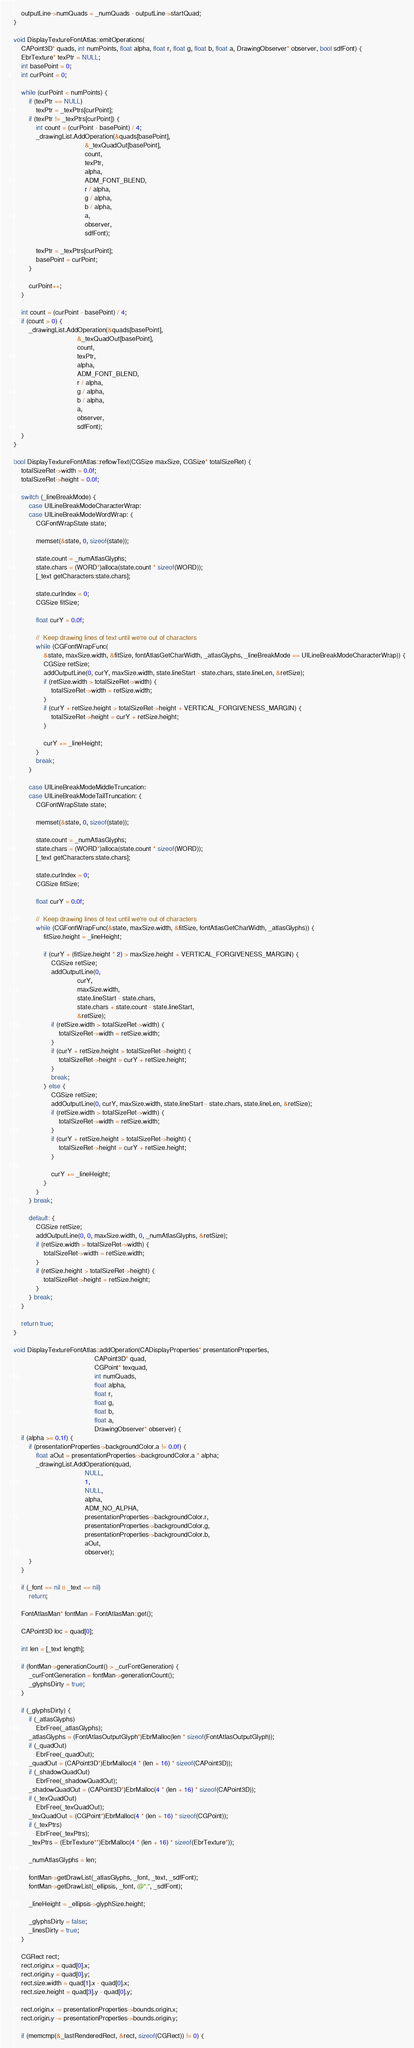<code> <loc_0><loc_0><loc_500><loc_500><_ObjectiveC_>
    outputLine->numQuads = _numQuads - outputLine->startQuad;
}

void DisplayTextureFontAtlas::emitOperations(
    CAPoint3D* quads, int numPoints, float alpha, float r, float g, float b, float a, DrawingObserver* observer, bool sdfFont) {
    EbrTexture* texPtr = NULL;
    int basePoint = 0;
    int curPoint = 0;

    while (curPoint < numPoints) {
        if (texPtr == NULL)
            texPtr = _texPtrs[curPoint];
        if (texPtr != _texPtrs[curPoint]) {
            int count = (curPoint - basePoint) / 4;
            _drawingList.AddOperation(&quads[basePoint],
                                      &_texQuadOut[basePoint],
                                      count,
                                      texPtr,
                                      alpha,
                                      ADM_FONT_BLEND,
                                      r / alpha,
                                      g / alpha,
                                      b / alpha,
                                      a,
                                      observer,
                                      sdfFont);

            texPtr = _texPtrs[curPoint];
            basePoint = curPoint;
        }

        curPoint++;
    }

    int count = (curPoint - basePoint) / 4;
    if (count > 0) {
        _drawingList.AddOperation(&quads[basePoint],
                                  &_texQuadOut[basePoint],
                                  count,
                                  texPtr,
                                  alpha,
                                  ADM_FONT_BLEND,
                                  r / alpha,
                                  g / alpha,
                                  b / alpha,
                                  a,
                                  observer,
                                  sdfFont);
    }
}

bool DisplayTextureFontAtlas::reflowText(CGSize maxSize, CGSize* totalSizeRet) {
    totalSizeRet->width = 0.0f;
    totalSizeRet->height = 0.0f;

    switch (_lineBreakMode) {
        case UILineBreakModeCharacterWrap:
        case UILineBreakModeWordWrap: {
            CGFontWrapState state;

            memset(&state, 0, sizeof(state));

            state.count = _numAtlasGlyphs;
            state.chars = (WORD*)alloca(state.count * sizeof(WORD));
            [_text getCharacters:state.chars];

            state.curIndex = 0;
            CGSize fitSize;

            float curY = 0.0f;

            //  Keep drawing lines of text until we're out of characters
            while (CGFontWrapFunc(
                &state, maxSize.width, &fitSize, fontAtlasGetCharWidth, _atlasGlyphs, _lineBreakMode == UILineBreakModeCharacterWrap)) {
                CGSize retSize;
                addOutputLine(0, curY, maxSize.width, state.lineStart - state.chars, state.lineLen, &retSize);
                if (retSize.width > totalSizeRet->width) {
                    totalSizeRet->width = retSize.width;
                }
                if (curY + retSize.height > totalSizeRet->height + VERTICAL_FORGIVENESS_MARGIN) {
                    totalSizeRet->height = curY + retSize.height;
                }

                curY += _lineHeight;
            }
            break;
        }

        case UILineBreakModeMiddleTruncation:
        case UILineBreakModeTailTruncation: {
            CGFontWrapState state;

            memset(&state, 0, sizeof(state));

            state.count = _numAtlasGlyphs;
            state.chars = (WORD*)alloca(state.count * sizeof(WORD));
            [_text getCharacters:state.chars];

            state.curIndex = 0;
            CGSize fitSize;

            float curY = 0.0f;

            //  Keep drawing lines of text until we're out of characters
            while (CGFontWrapFunc(&state, maxSize.width, &fitSize, fontAtlasGetCharWidth, _atlasGlyphs)) {
                fitSize.height = _lineHeight;

                if (curY + (fitSize.height * 2) > maxSize.height + VERTICAL_FORGIVENESS_MARGIN) {
                    CGSize retSize;
                    addOutputLine(0,
                                  curY,
                                  maxSize.width,
                                  state.lineStart - state.chars,
                                  state.chars + state.count - state.lineStart,
                                  &retSize);
                    if (retSize.width > totalSizeRet->width) {
                        totalSizeRet->width = retSize.width;
                    }
                    if (curY + retSize.height > totalSizeRet->height) {
                        totalSizeRet->height = curY + retSize.height;
                    }
                    break;
                } else {
                    CGSize retSize;
                    addOutputLine(0, curY, maxSize.width, state.lineStart - state.chars, state.lineLen, &retSize);
                    if (retSize.width > totalSizeRet->width) {
                        totalSizeRet->width = retSize.width;
                    }
                    if (curY + retSize.height > totalSizeRet->height) {
                        totalSizeRet->height = curY + retSize.height;
                    }

                    curY += _lineHeight;
                }
            }
        } break;

        default: {
            CGSize retSize;
            addOutputLine(0, 0, maxSize.width, 0, _numAtlasGlyphs, &retSize);
            if (retSize.width > totalSizeRet->width) {
                totalSizeRet->width = retSize.width;
            }
            if (retSize.height > totalSizeRet->height) {
                totalSizeRet->height = retSize.height;
            }
        } break;
    }

    return true;
}

void DisplayTextureFontAtlas::addOperation(CADisplayProperties* presentationProperties,
                                           CAPoint3D* quad,
                                           CGPoint* texquad,
                                           int numQuads,
                                           float alpha,
                                           float r,
                                           float g,
                                           float b,
                                           float a,
                                           DrawingObserver* observer) {
    if (alpha >= 0.1f) {
        if (presentationProperties->backgroundColor.a != 0.0f) {
            float aOut = presentationProperties->backgroundColor.a * alpha;
            _drawingList.AddOperation(quad,
                                      NULL,
                                      1,
                                      NULL,
                                      alpha,
                                      ADM_NO_ALPHA,
                                      presentationProperties->backgroundColor.r,
                                      presentationProperties->backgroundColor.g,
                                      presentationProperties->backgroundColor.b,
                                      aOut,
                                      observer);
        }
    }

    if (_font == nil || _text == nil)
        return;

    FontAtlasMan* fontMan = FontAtlasMan::get();

    CAPoint3D loc = quad[0];

    int len = [_text length];

    if (fontMan->generationCount() > _curFontGeneration) {
        _curFontGeneration = fontMan->generationCount();
        _glyphsDirty = true;
    }

    if (_glyphsDirty) {
        if (_atlasGlyphs)
            EbrFree(_atlasGlyphs);
        _atlasGlyphs = (FontAtlasOutputGlyph*)EbrMalloc(len * sizeof(FontAtlasOutputGlyph));
        if (_quadOut)
            EbrFree(_quadOut);
        _quadOut = (CAPoint3D*)EbrMalloc(4 * (len + 16) * sizeof(CAPoint3D));
        if (_shadowQuadOut)
            EbrFree(_shadowQuadOut);
        _shadowQuadOut = (CAPoint3D*)EbrMalloc(4 * (len + 16) * sizeof(CAPoint3D));
        if (_texQuadOut)
            EbrFree(_texQuadOut);
        _texQuadOut = (CGPoint*)EbrMalloc(4 * (len + 16) * sizeof(CGPoint));
        if (_texPtrs)
            EbrFree(_texPtrs);
        _texPtrs = (EbrTexture**)EbrMalloc(4 * (len + 16) * sizeof(EbrTexture*));

        _numAtlasGlyphs = len;

        fontMan->getDrawList(_atlasGlyphs, _font, _text, _sdfFont);
        fontMan->getDrawList(_ellipsis, _font, @".", _sdfFont);

        _lineHeight = _ellipsis->glyphSize.height;

        _glyphsDirty = false;
        _linesDirty = true;
    }

    CGRect rect;
    rect.origin.x = quad[0].x;
    rect.origin.y = quad[0].y;
    rect.size.width = quad[1].x - quad[0].x;
    rect.size.height = quad[3].y - quad[0].y;

    rect.origin.x -= presentationProperties->bounds.origin.x;
    rect.origin.y -= presentationProperties->bounds.origin.y;

    if (memcmp(&_lastRenderedRect, &rect, sizeof(CGRect)) != 0) {</code> 